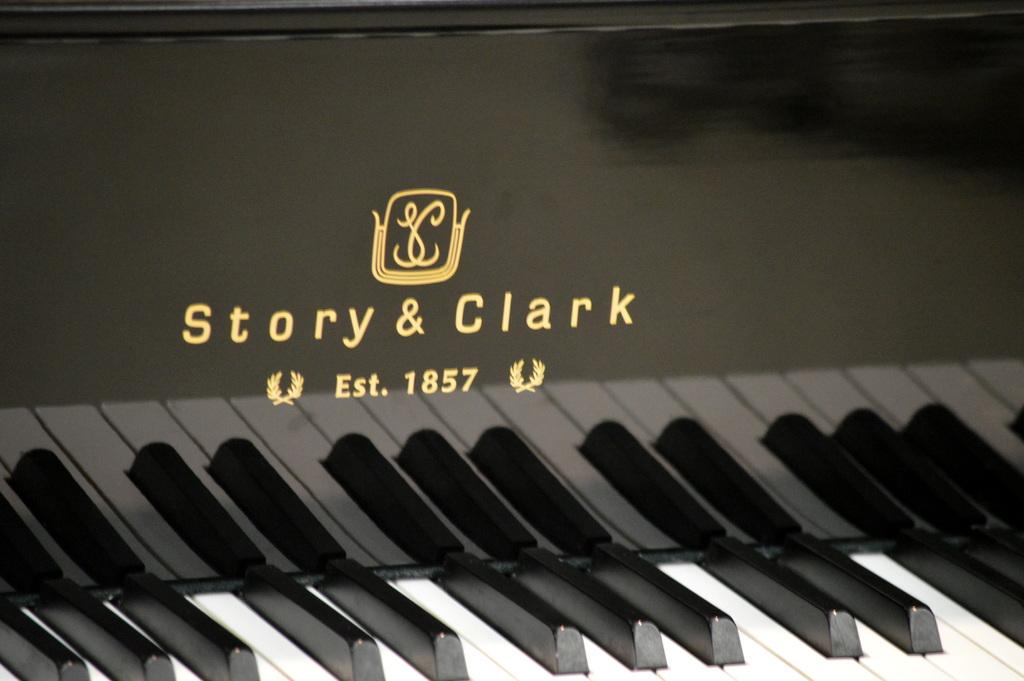What type of musical instrument is in the image? There is a musical keyboard in the image. What colors are used for the musical keyboard? The musical keyboard is black and white in color. What brand or manufacturer is the musical keyboard? The musical keyboard is labeled "Story and Clark." How does the owl contribute to the musical performance on the keyboard in the image? There is no owl present in the image, so it cannot contribute to the musical performance on the keyboard. 